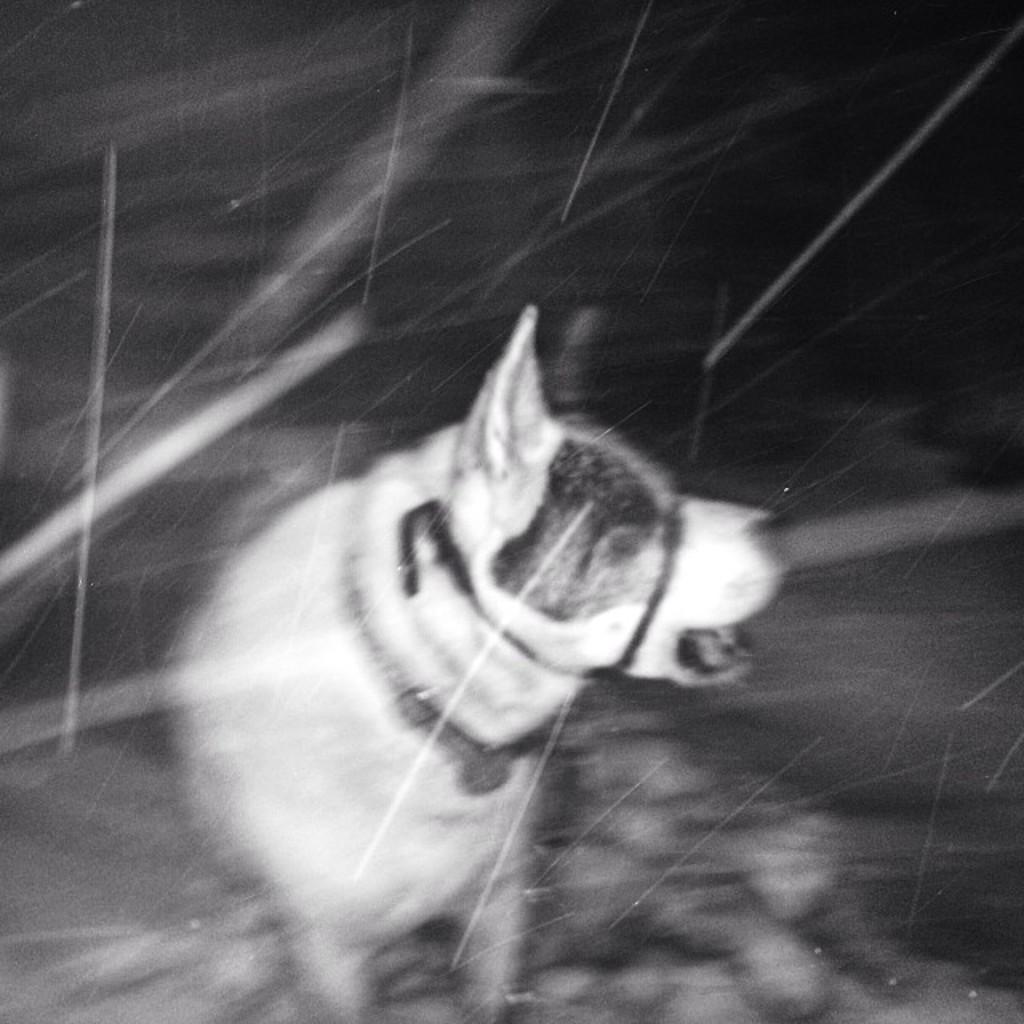Can you describe this image briefly? This is a black and white picture. I can see a dog standing, and there is blur background. 